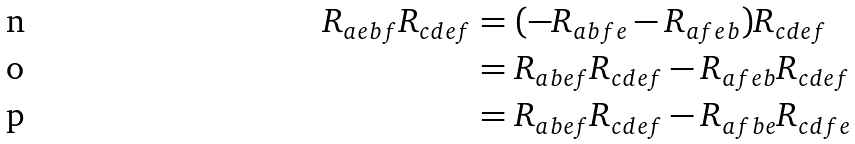<formula> <loc_0><loc_0><loc_500><loc_500>R _ { a e b f } R _ { c d e f } & = ( - R _ { a b f e } - R _ { a f e b } ) R _ { c d e f } \\ & = R _ { a b e f } R _ { c d e f } - R _ { a f e b } R _ { c d e f } \\ & = R _ { a b e f } R _ { c d e f } - R _ { a f b e } R _ { c d f e }</formula> 